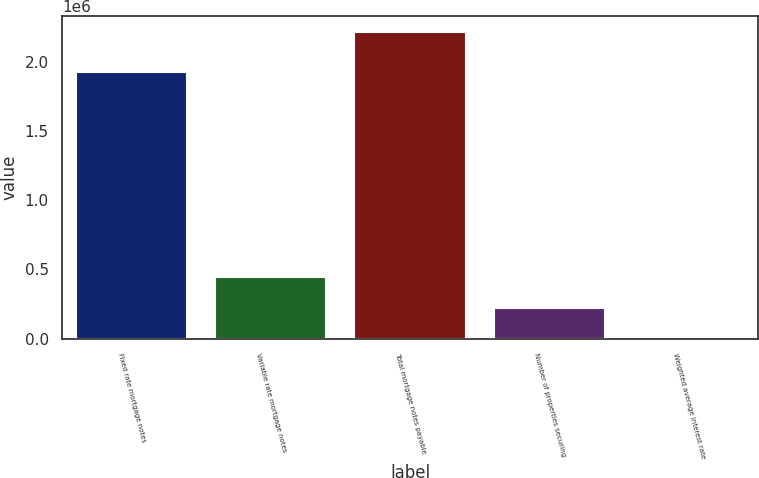Convert chart. <chart><loc_0><loc_0><loc_500><loc_500><bar_chart><fcel>Fixed rate mortgage notes<fcel>Variable rate mortgage notes<fcel>Total mortgage notes payable<fcel>Number of properties securing<fcel>Weighted average interest rate<nl><fcel>1.92598e+06<fcel>443019<fcel>2.21508e+06<fcel>221512<fcel>4.4<nl></chart> 